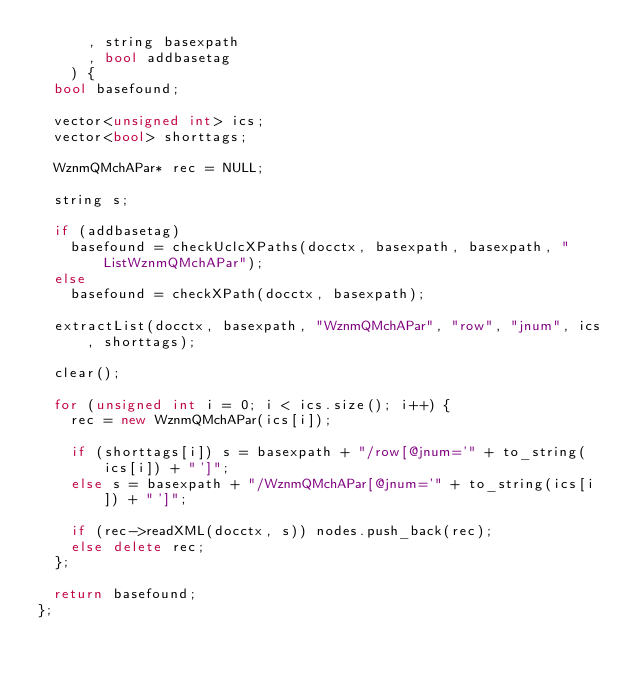Convert code to text. <code><loc_0><loc_0><loc_500><loc_500><_C++_>			, string basexpath
			, bool addbasetag
		) {
	bool basefound;

	vector<unsigned int> ics;
	vector<bool> shorttags;

	WznmQMchAPar* rec = NULL;

	string s;

	if (addbasetag)
		basefound = checkUclcXPaths(docctx, basexpath, basexpath, "ListWznmQMchAPar");
	else
		basefound = checkXPath(docctx, basexpath);

	extractList(docctx, basexpath, "WznmQMchAPar", "row", "jnum", ics, shorttags);

	clear();

	for (unsigned int i = 0; i < ics.size(); i++) {
		rec = new WznmQMchAPar(ics[i]);

		if (shorttags[i]) s = basexpath + "/row[@jnum='" + to_string(ics[i]) + "']";
		else s = basexpath + "/WznmQMchAPar[@jnum='" + to_string(ics[i]) + "']";

		if (rec->readXML(docctx, s)) nodes.push_back(rec);
		else delete rec;
	};

	return basefound;
};
</code> 